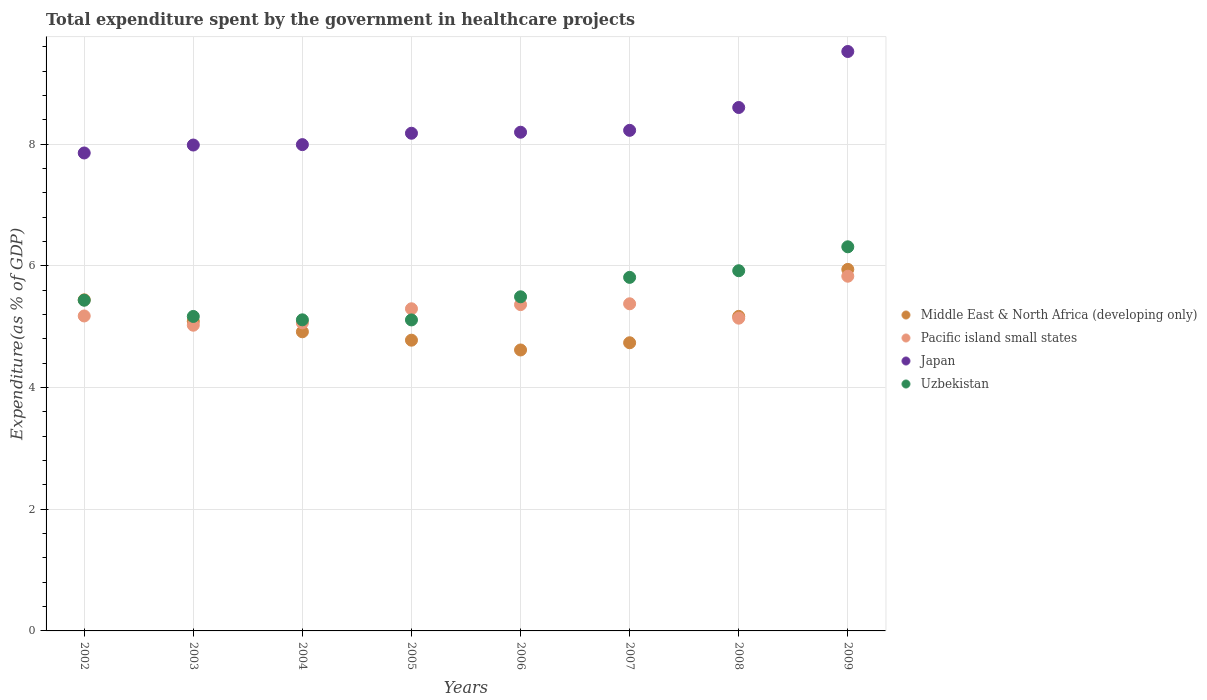What is the total expenditure spent by the government in healthcare projects in Uzbekistan in 2006?
Keep it short and to the point. 5.49. Across all years, what is the maximum total expenditure spent by the government in healthcare projects in Japan?
Keep it short and to the point. 9.53. Across all years, what is the minimum total expenditure spent by the government in healthcare projects in Middle East & North Africa (developing only)?
Offer a terse response. 4.62. In which year was the total expenditure spent by the government in healthcare projects in Japan maximum?
Offer a very short reply. 2009. What is the total total expenditure spent by the government in healthcare projects in Middle East & North Africa (developing only) in the graph?
Your answer should be very brief. 40.7. What is the difference between the total expenditure spent by the government in healthcare projects in Middle East & North Africa (developing only) in 2003 and that in 2009?
Your response must be concise. -0.85. What is the difference between the total expenditure spent by the government in healthcare projects in Middle East & North Africa (developing only) in 2006 and the total expenditure spent by the government in healthcare projects in Pacific island small states in 2003?
Provide a succinct answer. -0.41. What is the average total expenditure spent by the government in healthcare projects in Middle East & North Africa (developing only) per year?
Your answer should be compact. 5.09. In the year 2008, what is the difference between the total expenditure spent by the government in healthcare projects in Pacific island small states and total expenditure spent by the government in healthcare projects in Japan?
Your response must be concise. -3.46. In how many years, is the total expenditure spent by the government in healthcare projects in Pacific island small states greater than 2.8 %?
Your response must be concise. 8. What is the ratio of the total expenditure spent by the government in healthcare projects in Pacific island small states in 2005 to that in 2007?
Offer a terse response. 0.98. Is the difference between the total expenditure spent by the government in healthcare projects in Pacific island small states in 2005 and 2009 greater than the difference between the total expenditure spent by the government in healthcare projects in Japan in 2005 and 2009?
Offer a terse response. Yes. What is the difference between the highest and the second highest total expenditure spent by the government in healthcare projects in Middle East & North Africa (developing only)?
Your response must be concise. 0.5. What is the difference between the highest and the lowest total expenditure spent by the government in healthcare projects in Pacific island small states?
Keep it short and to the point. 0.81. In how many years, is the total expenditure spent by the government in healthcare projects in Japan greater than the average total expenditure spent by the government in healthcare projects in Japan taken over all years?
Keep it short and to the point. 2. Is the sum of the total expenditure spent by the government in healthcare projects in Pacific island small states in 2008 and 2009 greater than the maximum total expenditure spent by the government in healthcare projects in Japan across all years?
Offer a terse response. Yes. Is it the case that in every year, the sum of the total expenditure spent by the government in healthcare projects in Pacific island small states and total expenditure spent by the government in healthcare projects in Japan  is greater than the total expenditure spent by the government in healthcare projects in Uzbekistan?
Offer a terse response. Yes. Does the total expenditure spent by the government in healthcare projects in Japan monotonically increase over the years?
Your answer should be compact. Yes. Is the total expenditure spent by the government in healthcare projects in Uzbekistan strictly less than the total expenditure spent by the government in healthcare projects in Japan over the years?
Your answer should be compact. Yes. How many dotlines are there?
Keep it short and to the point. 4. How many years are there in the graph?
Your response must be concise. 8. Does the graph contain grids?
Keep it short and to the point. Yes. Where does the legend appear in the graph?
Offer a terse response. Center right. How are the legend labels stacked?
Offer a very short reply. Vertical. What is the title of the graph?
Provide a succinct answer. Total expenditure spent by the government in healthcare projects. What is the label or title of the Y-axis?
Provide a succinct answer. Expenditure(as % of GDP). What is the Expenditure(as % of GDP) in Middle East & North Africa (developing only) in 2002?
Offer a terse response. 5.44. What is the Expenditure(as % of GDP) in Pacific island small states in 2002?
Offer a very short reply. 5.18. What is the Expenditure(as % of GDP) of Japan in 2002?
Offer a very short reply. 7.86. What is the Expenditure(as % of GDP) of Uzbekistan in 2002?
Your answer should be very brief. 5.44. What is the Expenditure(as % of GDP) in Middle East & North Africa (developing only) in 2003?
Provide a succinct answer. 5.09. What is the Expenditure(as % of GDP) in Pacific island small states in 2003?
Ensure brevity in your answer.  5.03. What is the Expenditure(as % of GDP) in Japan in 2003?
Keep it short and to the point. 7.99. What is the Expenditure(as % of GDP) of Uzbekistan in 2003?
Provide a short and direct response. 5.17. What is the Expenditure(as % of GDP) of Middle East & North Africa (developing only) in 2004?
Your answer should be compact. 4.92. What is the Expenditure(as % of GDP) of Pacific island small states in 2004?
Make the answer very short. 5.06. What is the Expenditure(as % of GDP) of Japan in 2004?
Offer a terse response. 7.99. What is the Expenditure(as % of GDP) in Uzbekistan in 2004?
Offer a terse response. 5.11. What is the Expenditure(as % of GDP) in Middle East & North Africa (developing only) in 2005?
Ensure brevity in your answer.  4.78. What is the Expenditure(as % of GDP) in Pacific island small states in 2005?
Make the answer very short. 5.3. What is the Expenditure(as % of GDP) in Japan in 2005?
Offer a very short reply. 8.18. What is the Expenditure(as % of GDP) in Uzbekistan in 2005?
Keep it short and to the point. 5.11. What is the Expenditure(as % of GDP) in Middle East & North Africa (developing only) in 2006?
Offer a terse response. 4.62. What is the Expenditure(as % of GDP) in Pacific island small states in 2006?
Offer a very short reply. 5.36. What is the Expenditure(as % of GDP) in Japan in 2006?
Provide a succinct answer. 8.2. What is the Expenditure(as % of GDP) of Uzbekistan in 2006?
Give a very brief answer. 5.49. What is the Expenditure(as % of GDP) of Middle East & North Africa (developing only) in 2007?
Make the answer very short. 4.74. What is the Expenditure(as % of GDP) in Pacific island small states in 2007?
Ensure brevity in your answer.  5.38. What is the Expenditure(as % of GDP) in Japan in 2007?
Keep it short and to the point. 8.23. What is the Expenditure(as % of GDP) of Uzbekistan in 2007?
Offer a very short reply. 5.81. What is the Expenditure(as % of GDP) of Middle East & North Africa (developing only) in 2008?
Provide a short and direct response. 5.17. What is the Expenditure(as % of GDP) in Pacific island small states in 2008?
Give a very brief answer. 5.14. What is the Expenditure(as % of GDP) of Japan in 2008?
Keep it short and to the point. 8.61. What is the Expenditure(as % of GDP) of Uzbekistan in 2008?
Ensure brevity in your answer.  5.92. What is the Expenditure(as % of GDP) in Middle East & North Africa (developing only) in 2009?
Ensure brevity in your answer.  5.94. What is the Expenditure(as % of GDP) in Pacific island small states in 2009?
Give a very brief answer. 5.83. What is the Expenditure(as % of GDP) of Japan in 2009?
Your answer should be very brief. 9.53. What is the Expenditure(as % of GDP) in Uzbekistan in 2009?
Offer a very short reply. 6.31. Across all years, what is the maximum Expenditure(as % of GDP) of Middle East & North Africa (developing only)?
Give a very brief answer. 5.94. Across all years, what is the maximum Expenditure(as % of GDP) of Pacific island small states?
Your answer should be compact. 5.83. Across all years, what is the maximum Expenditure(as % of GDP) of Japan?
Your response must be concise. 9.53. Across all years, what is the maximum Expenditure(as % of GDP) in Uzbekistan?
Give a very brief answer. 6.31. Across all years, what is the minimum Expenditure(as % of GDP) in Middle East & North Africa (developing only)?
Offer a very short reply. 4.62. Across all years, what is the minimum Expenditure(as % of GDP) in Pacific island small states?
Give a very brief answer. 5.03. Across all years, what is the minimum Expenditure(as % of GDP) of Japan?
Make the answer very short. 7.86. Across all years, what is the minimum Expenditure(as % of GDP) in Uzbekistan?
Keep it short and to the point. 5.11. What is the total Expenditure(as % of GDP) in Middle East & North Africa (developing only) in the graph?
Your response must be concise. 40.7. What is the total Expenditure(as % of GDP) of Pacific island small states in the graph?
Your answer should be very brief. 42.28. What is the total Expenditure(as % of GDP) of Japan in the graph?
Your response must be concise. 66.58. What is the total Expenditure(as % of GDP) in Uzbekistan in the graph?
Your answer should be compact. 44.38. What is the difference between the Expenditure(as % of GDP) in Middle East & North Africa (developing only) in 2002 and that in 2003?
Your answer should be very brief. 0.35. What is the difference between the Expenditure(as % of GDP) of Pacific island small states in 2002 and that in 2003?
Offer a terse response. 0.15. What is the difference between the Expenditure(as % of GDP) of Japan in 2002 and that in 2003?
Give a very brief answer. -0.13. What is the difference between the Expenditure(as % of GDP) of Uzbekistan in 2002 and that in 2003?
Your answer should be compact. 0.27. What is the difference between the Expenditure(as % of GDP) in Middle East & North Africa (developing only) in 2002 and that in 2004?
Make the answer very short. 0.53. What is the difference between the Expenditure(as % of GDP) in Pacific island small states in 2002 and that in 2004?
Your answer should be very brief. 0.11. What is the difference between the Expenditure(as % of GDP) in Japan in 2002 and that in 2004?
Your answer should be compact. -0.14. What is the difference between the Expenditure(as % of GDP) of Uzbekistan in 2002 and that in 2004?
Give a very brief answer. 0.32. What is the difference between the Expenditure(as % of GDP) of Middle East & North Africa (developing only) in 2002 and that in 2005?
Offer a very short reply. 0.66. What is the difference between the Expenditure(as % of GDP) in Pacific island small states in 2002 and that in 2005?
Give a very brief answer. -0.12. What is the difference between the Expenditure(as % of GDP) of Japan in 2002 and that in 2005?
Provide a succinct answer. -0.32. What is the difference between the Expenditure(as % of GDP) of Uzbekistan in 2002 and that in 2005?
Provide a short and direct response. 0.32. What is the difference between the Expenditure(as % of GDP) of Middle East & North Africa (developing only) in 2002 and that in 2006?
Ensure brevity in your answer.  0.82. What is the difference between the Expenditure(as % of GDP) in Pacific island small states in 2002 and that in 2006?
Your answer should be very brief. -0.19. What is the difference between the Expenditure(as % of GDP) of Japan in 2002 and that in 2006?
Your answer should be compact. -0.34. What is the difference between the Expenditure(as % of GDP) of Uzbekistan in 2002 and that in 2006?
Keep it short and to the point. -0.06. What is the difference between the Expenditure(as % of GDP) in Middle East & North Africa (developing only) in 2002 and that in 2007?
Ensure brevity in your answer.  0.71. What is the difference between the Expenditure(as % of GDP) in Pacific island small states in 2002 and that in 2007?
Offer a very short reply. -0.2. What is the difference between the Expenditure(as % of GDP) in Japan in 2002 and that in 2007?
Ensure brevity in your answer.  -0.37. What is the difference between the Expenditure(as % of GDP) in Uzbekistan in 2002 and that in 2007?
Provide a succinct answer. -0.38. What is the difference between the Expenditure(as % of GDP) in Middle East & North Africa (developing only) in 2002 and that in 2008?
Ensure brevity in your answer.  0.27. What is the difference between the Expenditure(as % of GDP) in Pacific island small states in 2002 and that in 2008?
Your answer should be compact. 0.04. What is the difference between the Expenditure(as % of GDP) in Japan in 2002 and that in 2008?
Your answer should be compact. -0.75. What is the difference between the Expenditure(as % of GDP) of Uzbekistan in 2002 and that in 2008?
Ensure brevity in your answer.  -0.48. What is the difference between the Expenditure(as % of GDP) in Middle East & North Africa (developing only) in 2002 and that in 2009?
Ensure brevity in your answer.  -0.5. What is the difference between the Expenditure(as % of GDP) in Pacific island small states in 2002 and that in 2009?
Offer a very short reply. -0.65. What is the difference between the Expenditure(as % of GDP) in Japan in 2002 and that in 2009?
Make the answer very short. -1.67. What is the difference between the Expenditure(as % of GDP) in Uzbekistan in 2002 and that in 2009?
Ensure brevity in your answer.  -0.88. What is the difference between the Expenditure(as % of GDP) of Middle East & North Africa (developing only) in 2003 and that in 2004?
Offer a very short reply. 0.17. What is the difference between the Expenditure(as % of GDP) in Pacific island small states in 2003 and that in 2004?
Provide a short and direct response. -0.04. What is the difference between the Expenditure(as % of GDP) of Japan in 2003 and that in 2004?
Provide a short and direct response. -0.01. What is the difference between the Expenditure(as % of GDP) of Uzbekistan in 2003 and that in 2004?
Provide a succinct answer. 0.06. What is the difference between the Expenditure(as % of GDP) of Middle East & North Africa (developing only) in 2003 and that in 2005?
Keep it short and to the point. 0.31. What is the difference between the Expenditure(as % of GDP) in Pacific island small states in 2003 and that in 2005?
Give a very brief answer. -0.27. What is the difference between the Expenditure(as % of GDP) in Japan in 2003 and that in 2005?
Provide a short and direct response. -0.19. What is the difference between the Expenditure(as % of GDP) of Uzbekistan in 2003 and that in 2005?
Make the answer very short. 0.06. What is the difference between the Expenditure(as % of GDP) in Middle East & North Africa (developing only) in 2003 and that in 2006?
Your answer should be compact. 0.47. What is the difference between the Expenditure(as % of GDP) in Pacific island small states in 2003 and that in 2006?
Ensure brevity in your answer.  -0.34. What is the difference between the Expenditure(as % of GDP) in Japan in 2003 and that in 2006?
Your answer should be compact. -0.21. What is the difference between the Expenditure(as % of GDP) in Uzbekistan in 2003 and that in 2006?
Offer a terse response. -0.32. What is the difference between the Expenditure(as % of GDP) in Middle East & North Africa (developing only) in 2003 and that in 2007?
Offer a very short reply. 0.35. What is the difference between the Expenditure(as % of GDP) in Pacific island small states in 2003 and that in 2007?
Offer a terse response. -0.35. What is the difference between the Expenditure(as % of GDP) in Japan in 2003 and that in 2007?
Your response must be concise. -0.24. What is the difference between the Expenditure(as % of GDP) of Uzbekistan in 2003 and that in 2007?
Offer a terse response. -0.64. What is the difference between the Expenditure(as % of GDP) in Middle East & North Africa (developing only) in 2003 and that in 2008?
Give a very brief answer. -0.08. What is the difference between the Expenditure(as % of GDP) in Pacific island small states in 2003 and that in 2008?
Your response must be concise. -0.12. What is the difference between the Expenditure(as % of GDP) of Japan in 2003 and that in 2008?
Your answer should be very brief. -0.62. What is the difference between the Expenditure(as % of GDP) in Uzbekistan in 2003 and that in 2008?
Offer a terse response. -0.75. What is the difference between the Expenditure(as % of GDP) of Middle East & North Africa (developing only) in 2003 and that in 2009?
Give a very brief answer. -0.85. What is the difference between the Expenditure(as % of GDP) of Pacific island small states in 2003 and that in 2009?
Offer a terse response. -0.81. What is the difference between the Expenditure(as % of GDP) in Japan in 2003 and that in 2009?
Offer a terse response. -1.54. What is the difference between the Expenditure(as % of GDP) in Uzbekistan in 2003 and that in 2009?
Offer a very short reply. -1.14. What is the difference between the Expenditure(as % of GDP) in Middle East & North Africa (developing only) in 2004 and that in 2005?
Provide a short and direct response. 0.14. What is the difference between the Expenditure(as % of GDP) in Pacific island small states in 2004 and that in 2005?
Your response must be concise. -0.23. What is the difference between the Expenditure(as % of GDP) of Japan in 2004 and that in 2005?
Keep it short and to the point. -0.19. What is the difference between the Expenditure(as % of GDP) in Uzbekistan in 2004 and that in 2005?
Offer a terse response. 0. What is the difference between the Expenditure(as % of GDP) in Middle East & North Africa (developing only) in 2004 and that in 2006?
Provide a short and direct response. 0.3. What is the difference between the Expenditure(as % of GDP) in Pacific island small states in 2004 and that in 2006?
Provide a short and direct response. -0.3. What is the difference between the Expenditure(as % of GDP) in Japan in 2004 and that in 2006?
Provide a short and direct response. -0.2. What is the difference between the Expenditure(as % of GDP) of Uzbekistan in 2004 and that in 2006?
Give a very brief answer. -0.38. What is the difference between the Expenditure(as % of GDP) in Middle East & North Africa (developing only) in 2004 and that in 2007?
Your answer should be compact. 0.18. What is the difference between the Expenditure(as % of GDP) in Pacific island small states in 2004 and that in 2007?
Your answer should be very brief. -0.31. What is the difference between the Expenditure(as % of GDP) of Japan in 2004 and that in 2007?
Make the answer very short. -0.23. What is the difference between the Expenditure(as % of GDP) in Uzbekistan in 2004 and that in 2007?
Your response must be concise. -0.7. What is the difference between the Expenditure(as % of GDP) of Middle East & North Africa (developing only) in 2004 and that in 2008?
Ensure brevity in your answer.  -0.25. What is the difference between the Expenditure(as % of GDP) of Pacific island small states in 2004 and that in 2008?
Provide a short and direct response. -0.08. What is the difference between the Expenditure(as % of GDP) of Japan in 2004 and that in 2008?
Keep it short and to the point. -0.61. What is the difference between the Expenditure(as % of GDP) of Uzbekistan in 2004 and that in 2008?
Your answer should be very brief. -0.81. What is the difference between the Expenditure(as % of GDP) in Middle East & North Africa (developing only) in 2004 and that in 2009?
Provide a short and direct response. -1.03. What is the difference between the Expenditure(as % of GDP) of Pacific island small states in 2004 and that in 2009?
Ensure brevity in your answer.  -0.77. What is the difference between the Expenditure(as % of GDP) of Japan in 2004 and that in 2009?
Make the answer very short. -1.53. What is the difference between the Expenditure(as % of GDP) in Uzbekistan in 2004 and that in 2009?
Your answer should be compact. -1.2. What is the difference between the Expenditure(as % of GDP) in Middle East & North Africa (developing only) in 2005 and that in 2006?
Keep it short and to the point. 0.16. What is the difference between the Expenditure(as % of GDP) of Pacific island small states in 2005 and that in 2006?
Make the answer very short. -0.07. What is the difference between the Expenditure(as % of GDP) of Japan in 2005 and that in 2006?
Ensure brevity in your answer.  -0.02. What is the difference between the Expenditure(as % of GDP) in Uzbekistan in 2005 and that in 2006?
Your response must be concise. -0.38. What is the difference between the Expenditure(as % of GDP) of Middle East & North Africa (developing only) in 2005 and that in 2007?
Ensure brevity in your answer.  0.04. What is the difference between the Expenditure(as % of GDP) of Pacific island small states in 2005 and that in 2007?
Your response must be concise. -0.08. What is the difference between the Expenditure(as % of GDP) of Japan in 2005 and that in 2007?
Keep it short and to the point. -0.05. What is the difference between the Expenditure(as % of GDP) of Uzbekistan in 2005 and that in 2007?
Offer a very short reply. -0.7. What is the difference between the Expenditure(as % of GDP) of Middle East & North Africa (developing only) in 2005 and that in 2008?
Keep it short and to the point. -0.39. What is the difference between the Expenditure(as % of GDP) in Pacific island small states in 2005 and that in 2008?
Provide a short and direct response. 0.15. What is the difference between the Expenditure(as % of GDP) in Japan in 2005 and that in 2008?
Offer a terse response. -0.42. What is the difference between the Expenditure(as % of GDP) of Uzbekistan in 2005 and that in 2008?
Provide a short and direct response. -0.81. What is the difference between the Expenditure(as % of GDP) of Middle East & North Africa (developing only) in 2005 and that in 2009?
Offer a very short reply. -1.16. What is the difference between the Expenditure(as % of GDP) of Pacific island small states in 2005 and that in 2009?
Offer a terse response. -0.54. What is the difference between the Expenditure(as % of GDP) of Japan in 2005 and that in 2009?
Offer a very short reply. -1.34. What is the difference between the Expenditure(as % of GDP) in Uzbekistan in 2005 and that in 2009?
Your answer should be very brief. -1.2. What is the difference between the Expenditure(as % of GDP) in Middle East & North Africa (developing only) in 2006 and that in 2007?
Give a very brief answer. -0.12. What is the difference between the Expenditure(as % of GDP) of Pacific island small states in 2006 and that in 2007?
Keep it short and to the point. -0.01. What is the difference between the Expenditure(as % of GDP) in Japan in 2006 and that in 2007?
Your answer should be compact. -0.03. What is the difference between the Expenditure(as % of GDP) in Uzbekistan in 2006 and that in 2007?
Offer a terse response. -0.32. What is the difference between the Expenditure(as % of GDP) of Middle East & North Africa (developing only) in 2006 and that in 2008?
Offer a very short reply. -0.55. What is the difference between the Expenditure(as % of GDP) in Pacific island small states in 2006 and that in 2008?
Provide a short and direct response. 0.22. What is the difference between the Expenditure(as % of GDP) in Japan in 2006 and that in 2008?
Offer a terse response. -0.41. What is the difference between the Expenditure(as % of GDP) of Uzbekistan in 2006 and that in 2008?
Provide a short and direct response. -0.43. What is the difference between the Expenditure(as % of GDP) of Middle East & North Africa (developing only) in 2006 and that in 2009?
Ensure brevity in your answer.  -1.32. What is the difference between the Expenditure(as % of GDP) of Pacific island small states in 2006 and that in 2009?
Offer a terse response. -0.47. What is the difference between the Expenditure(as % of GDP) in Japan in 2006 and that in 2009?
Ensure brevity in your answer.  -1.33. What is the difference between the Expenditure(as % of GDP) of Uzbekistan in 2006 and that in 2009?
Your answer should be compact. -0.82. What is the difference between the Expenditure(as % of GDP) of Middle East & North Africa (developing only) in 2007 and that in 2008?
Offer a terse response. -0.43. What is the difference between the Expenditure(as % of GDP) of Pacific island small states in 2007 and that in 2008?
Make the answer very short. 0.24. What is the difference between the Expenditure(as % of GDP) of Japan in 2007 and that in 2008?
Provide a short and direct response. -0.38. What is the difference between the Expenditure(as % of GDP) in Uzbekistan in 2007 and that in 2008?
Make the answer very short. -0.11. What is the difference between the Expenditure(as % of GDP) in Middle East & North Africa (developing only) in 2007 and that in 2009?
Provide a short and direct response. -1.21. What is the difference between the Expenditure(as % of GDP) of Pacific island small states in 2007 and that in 2009?
Make the answer very short. -0.45. What is the difference between the Expenditure(as % of GDP) of Japan in 2007 and that in 2009?
Your response must be concise. -1.3. What is the difference between the Expenditure(as % of GDP) in Uzbekistan in 2007 and that in 2009?
Your answer should be very brief. -0.5. What is the difference between the Expenditure(as % of GDP) of Middle East & North Africa (developing only) in 2008 and that in 2009?
Offer a very short reply. -0.77. What is the difference between the Expenditure(as % of GDP) in Pacific island small states in 2008 and that in 2009?
Make the answer very short. -0.69. What is the difference between the Expenditure(as % of GDP) in Japan in 2008 and that in 2009?
Your response must be concise. -0.92. What is the difference between the Expenditure(as % of GDP) of Uzbekistan in 2008 and that in 2009?
Offer a very short reply. -0.39. What is the difference between the Expenditure(as % of GDP) in Middle East & North Africa (developing only) in 2002 and the Expenditure(as % of GDP) in Pacific island small states in 2003?
Provide a short and direct response. 0.42. What is the difference between the Expenditure(as % of GDP) of Middle East & North Africa (developing only) in 2002 and the Expenditure(as % of GDP) of Japan in 2003?
Offer a very short reply. -2.55. What is the difference between the Expenditure(as % of GDP) of Middle East & North Africa (developing only) in 2002 and the Expenditure(as % of GDP) of Uzbekistan in 2003?
Ensure brevity in your answer.  0.27. What is the difference between the Expenditure(as % of GDP) in Pacific island small states in 2002 and the Expenditure(as % of GDP) in Japan in 2003?
Offer a very short reply. -2.81. What is the difference between the Expenditure(as % of GDP) in Pacific island small states in 2002 and the Expenditure(as % of GDP) in Uzbekistan in 2003?
Keep it short and to the point. 0.01. What is the difference between the Expenditure(as % of GDP) in Japan in 2002 and the Expenditure(as % of GDP) in Uzbekistan in 2003?
Your answer should be very brief. 2.69. What is the difference between the Expenditure(as % of GDP) of Middle East & North Africa (developing only) in 2002 and the Expenditure(as % of GDP) of Pacific island small states in 2004?
Offer a terse response. 0.38. What is the difference between the Expenditure(as % of GDP) in Middle East & North Africa (developing only) in 2002 and the Expenditure(as % of GDP) in Japan in 2004?
Your response must be concise. -2.55. What is the difference between the Expenditure(as % of GDP) in Middle East & North Africa (developing only) in 2002 and the Expenditure(as % of GDP) in Uzbekistan in 2004?
Make the answer very short. 0.33. What is the difference between the Expenditure(as % of GDP) of Pacific island small states in 2002 and the Expenditure(as % of GDP) of Japan in 2004?
Provide a succinct answer. -2.82. What is the difference between the Expenditure(as % of GDP) in Pacific island small states in 2002 and the Expenditure(as % of GDP) in Uzbekistan in 2004?
Provide a succinct answer. 0.06. What is the difference between the Expenditure(as % of GDP) of Japan in 2002 and the Expenditure(as % of GDP) of Uzbekistan in 2004?
Your response must be concise. 2.74. What is the difference between the Expenditure(as % of GDP) of Middle East & North Africa (developing only) in 2002 and the Expenditure(as % of GDP) of Pacific island small states in 2005?
Make the answer very short. 0.15. What is the difference between the Expenditure(as % of GDP) in Middle East & North Africa (developing only) in 2002 and the Expenditure(as % of GDP) in Japan in 2005?
Your answer should be very brief. -2.74. What is the difference between the Expenditure(as % of GDP) of Middle East & North Africa (developing only) in 2002 and the Expenditure(as % of GDP) of Uzbekistan in 2005?
Keep it short and to the point. 0.33. What is the difference between the Expenditure(as % of GDP) of Pacific island small states in 2002 and the Expenditure(as % of GDP) of Japan in 2005?
Your response must be concise. -3. What is the difference between the Expenditure(as % of GDP) in Pacific island small states in 2002 and the Expenditure(as % of GDP) in Uzbekistan in 2005?
Offer a terse response. 0.07. What is the difference between the Expenditure(as % of GDP) in Japan in 2002 and the Expenditure(as % of GDP) in Uzbekistan in 2005?
Make the answer very short. 2.74. What is the difference between the Expenditure(as % of GDP) of Middle East & North Africa (developing only) in 2002 and the Expenditure(as % of GDP) of Pacific island small states in 2006?
Offer a terse response. 0.08. What is the difference between the Expenditure(as % of GDP) of Middle East & North Africa (developing only) in 2002 and the Expenditure(as % of GDP) of Japan in 2006?
Make the answer very short. -2.76. What is the difference between the Expenditure(as % of GDP) of Middle East & North Africa (developing only) in 2002 and the Expenditure(as % of GDP) of Uzbekistan in 2006?
Your answer should be very brief. -0.05. What is the difference between the Expenditure(as % of GDP) in Pacific island small states in 2002 and the Expenditure(as % of GDP) in Japan in 2006?
Your response must be concise. -3.02. What is the difference between the Expenditure(as % of GDP) in Pacific island small states in 2002 and the Expenditure(as % of GDP) in Uzbekistan in 2006?
Provide a short and direct response. -0.32. What is the difference between the Expenditure(as % of GDP) of Japan in 2002 and the Expenditure(as % of GDP) of Uzbekistan in 2006?
Provide a short and direct response. 2.36. What is the difference between the Expenditure(as % of GDP) in Middle East & North Africa (developing only) in 2002 and the Expenditure(as % of GDP) in Pacific island small states in 2007?
Offer a terse response. 0.06. What is the difference between the Expenditure(as % of GDP) in Middle East & North Africa (developing only) in 2002 and the Expenditure(as % of GDP) in Japan in 2007?
Provide a short and direct response. -2.79. What is the difference between the Expenditure(as % of GDP) in Middle East & North Africa (developing only) in 2002 and the Expenditure(as % of GDP) in Uzbekistan in 2007?
Make the answer very short. -0.37. What is the difference between the Expenditure(as % of GDP) of Pacific island small states in 2002 and the Expenditure(as % of GDP) of Japan in 2007?
Your response must be concise. -3.05. What is the difference between the Expenditure(as % of GDP) in Pacific island small states in 2002 and the Expenditure(as % of GDP) in Uzbekistan in 2007?
Provide a short and direct response. -0.63. What is the difference between the Expenditure(as % of GDP) of Japan in 2002 and the Expenditure(as % of GDP) of Uzbekistan in 2007?
Offer a very short reply. 2.05. What is the difference between the Expenditure(as % of GDP) in Middle East & North Africa (developing only) in 2002 and the Expenditure(as % of GDP) in Pacific island small states in 2008?
Ensure brevity in your answer.  0.3. What is the difference between the Expenditure(as % of GDP) in Middle East & North Africa (developing only) in 2002 and the Expenditure(as % of GDP) in Japan in 2008?
Keep it short and to the point. -3.16. What is the difference between the Expenditure(as % of GDP) in Middle East & North Africa (developing only) in 2002 and the Expenditure(as % of GDP) in Uzbekistan in 2008?
Ensure brevity in your answer.  -0.48. What is the difference between the Expenditure(as % of GDP) in Pacific island small states in 2002 and the Expenditure(as % of GDP) in Japan in 2008?
Your response must be concise. -3.43. What is the difference between the Expenditure(as % of GDP) of Pacific island small states in 2002 and the Expenditure(as % of GDP) of Uzbekistan in 2008?
Offer a very short reply. -0.74. What is the difference between the Expenditure(as % of GDP) of Japan in 2002 and the Expenditure(as % of GDP) of Uzbekistan in 2008?
Your answer should be compact. 1.94. What is the difference between the Expenditure(as % of GDP) in Middle East & North Africa (developing only) in 2002 and the Expenditure(as % of GDP) in Pacific island small states in 2009?
Your response must be concise. -0.39. What is the difference between the Expenditure(as % of GDP) of Middle East & North Africa (developing only) in 2002 and the Expenditure(as % of GDP) of Japan in 2009?
Offer a very short reply. -4.08. What is the difference between the Expenditure(as % of GDP) in Middle East & North Africa (developing only) in 2002 and the Expenditure(as % of GDP) in Uzbekistan in 2009?
Offer a terse response. -0.87. What is the difference between the Expenditure(as % of GDP) in Pacific island small states in 2002 and the Expenditure(as % of GDP) in Japan in 2009?
Ensure brevity in your answer.  -4.35. What is the difference between the Expenditure(as % of GDP) of Pacific island small states in 2002 and the Expenditure(as % of GDP) of Uzbekistan in 2009?
Make the answer very short. -1.14. What is the difference between the Expenditure(as % of GDP) of Japan in 2002 and the Expenditure(as % of GDP) of Uzbekistan in 2009?
Offer a very short reply. 1.54. What is the difference between the Expenditure(as % of GDP) of Middle East & North Africa (developing only) in 2003 and the Expenditure(as % of GDP) of Pacific island small states in 2004?
Offer a terse response. 0.03. What is the difference between the Expenditure(as % of GDP) in Middle East & North Africa (developing only) in 2003 and the Expenditure(as % of GDP) in Japan in 2004?
Give a very brief answer. -2.9. What is the difference between the Expenditure(as % of GDP) of Middle East & North Africa (developing only) in 2003 and the Expenditure(as % of GDP) of Uzbekistan in 2004?
Make the answer very short. -0.02. What is the difference between the Expenditure(as % of GDP) in Pacific island small states in 2003 and the Expenditure(as % of GDP) in Japan in 2004?
Give a very brief answer. -2.97. What is the difference between the Expenditure(as % of GDP) of Pacific island small states in 2003 and the Expenditure(as % of GDP) of Uzbekistan in 2004?
Keep it short and to the point. -0.09. What is the difference between the Expenditure(as % of GDP) of Japan in 2003 and the Expenditure(as % of GDP) of Uzbekistan in 2004?
Offer a terse response. 2.87. What is the difference between the Expenditure(as % of GDP) in Middle East & North Africa (developing only) in 2003 and the Expenditure(as % of GDP) in Pacific island small states in 2005?
Provide a short and direct response. -0.21. What is the difference between the Expenditure(as % of GDP) of Middle East & North Africa (developing only) in 2003 and the Expenditure(as % of GDP) of Japan in 2005?
Give a very brief answer. -3.09. What is the difference between the Expenditure(as % of GDP) of Middle East & North Africa (developing only) in 2003 and the Expenditure(as % of GDP) of Uzbekistan in 2005?
Provide a succinct answer. -0.02. What is the difference between the Expenditure(as % of GDP) of Pacific island small states in 2003 and the Expenditure(as % of GDP) of Japan in 2005?
Your response must be concise. -3.16. What is the difference between the Expenditure(as % of GDP) in Pacific island small states in 2003 and the Expenditure(as % of GDP) in Uzbekistan in 2005?
Your response must be concise. -0.09. What is the difference between the Expenditure(as % of GDP) in Japan in 2003 and the Expenditure(as % of GDP) in Uzbekistan in 2005?
Make the answer very short. 2.88. What is the difference between the Expenditure(as % of GDP) of Middle East & North Africa (developing only) in 2003 and the Expenditure(as % of GDP) of Pacific island small states in 2006?
Provide a short and direct response. -0.27. What is the difference between the Expenditure(as % of GDP) in Middle East & North Africa (developing only) in 2003 and the Expenditure(as % of GDP) in Japan in 2006?
Keep it short and to the point. -3.11. What is the difference between the Expenditure(as % of GDP) in Middle East & North Africa (developing only) in 2003 and the Expenditure(as % of GDP) in Uzbekistan in 2006?
Make the answer very short. -0.4. What is the difference between the Expenditure(as % of GDP) of Pacific island small states in 2003 and the Expenditure(as % of GDP) of Japan in 2006?
Provide a succinct answer. -3.17. What is the difference between the Expenditure(as % of GDP) of Pacific island small states in 2003 and the Expenditure(as % of GDP) of Uzbekistan in 2006?
Ensure brevity in your answer.  -0.47. What is the difference between the Expenditure(as % of GDP) of Japan in 2003 and the Expenditure(as % of GDP) of Uzbekistan in 2006?
Make the answer very short. 2.5. What is the difference between the Expenditure(as % of GDP) in Middle East & North Africa (developing only) in 2003 and the Expenditure(as % of GDP) in Pacific island small states in 2007?
Your answer should be compact. -0.29. What is the difference between the Expenditure(as % of GDP) in Middle East & North Africa (developing only) in 2003 and the Expenditure(as % of GDP) in Japan in 2007?
Provide a short and direct response. -3.14. What is the difference between the Expenditure(as % of GDP) of Middle East & North Africa (developing only) in 2003 and the Expenditure(as % of GDP) of Uzbekistan in 2007?
Ensure brevity in your answer.  -0.72. What is the difference between the Expenditure(as % of GDP) in Pacific island small states in 2003 and the Expenditure(as % of GDP) in Japan in 2007?
Your response must be concise. -3.2. What is the difference between the Expenditure(as % of GDP) in Pacific island small states in 2003 and the Expenditure(as % of GDP) in Uzbekistan in 2007?
Give a very brief answer. -0.79. What is the difference between the Expenditure(as % of GDP) of Japan in 2003 and the Expenditure(as % of GDP) of Uzbekistan in 2007?
Your response must be concise. 2.18. What is the difference between the Expenditure(as % of GDP) of Middle East & North Africa (developing only) in 2003 and the Expenditure(as % of GDP) of Pacific island small states in 2008?
Provide a short and direct response. -0.05. What is the difference between the Expenditure(as % of GDP) of Middle East & North Africa (developing only) in 2003 and the Expenditure(as % of GDP) of Japan in 2008?
Offer a terse response. -3.52. What is the difference between the Expenditure(as % of GDP) in Middle East & North Africa (developing only) in 2003 and the Expenditure(as % of GDP) in Uzbekistan in 2008?
Make the answer very short. -0.83. What is the difference between the Expenditure(as % of GDP) in Pacific island small states in 2003 and the Expenditure(as % of GDP) in Japan in 2008?
Make the answer very short. -3.58. What is the difference between the Expenditure(as % of GDP) of Pacific island small states in 2003 and the Expenditure(as % of GDP) of Uzbekistan in 2008?
Give a very brief answer. -0.9. What is the difference between the Expenditure(as % of GDP) of Japan in 2003 and the Expenditure(as % of GDP) of Uzbekistan in 2008?
Your answer should be compact. 2.07. What is the difference between the Expenditure(as % of GDP) of Middle East & North Africa (developing only) in 2003 and the Expenditure(as % of GDP) of Pacific island small states in 2009?
Make the answer very short. -0.74. What is the difference between the Expenditure(as % of GDP) of Middle East & North Africa (developing only) in 2003 and the Expenditure(as % of GDP) of Japan in 2009?
Offer a terse response. -4.44. What is the difference between the Expenditure(as % of GDP) of Middle East & North Africa (developing only) in 2003 and the Expenditure(as % of GDP) of Uzbekistan in 2009?
Make the answer very short. -1.23. What is the difference between the Expenditure(as % of GDP) of Pacific island small states in 2003 and the Expenditure(as % of GDP) of Japan in 2009?
Ensure brevity in your answer.  -4.5. What is the difference between the Expenditure(as % of GDP) in Pacific island small states in 2003 and the Expenditure(as % of GDP) in Uzbekistan in 2009?
Keep it short and to the point. -1.29. What is the difference between the Expenditure(as % of GDP) of Japan in 2003 and the Expenditure(as % of GDP) of Uzbekistan in 2009?
Give a very brief answer. 1.67. What is the difference between the Expenditure(as % of GDP) of Middle East & North Africa (developing only) in 2004 and the Expenditure(as % of GDP) of Pacific island small states in 2005?
Your answer should be compact. -0.38. What is the difference between the Expenditure(as % of GDP) in Middle East & North Africa (developing only) in 2004 and the Expenditure(as % of GDP) in Japan in 2005?
Offer a very short reply. -3.26. What is the difference between the Expenditure(as % of GDP) in Middle East & North Africa (developing only) in 2004 and the Expenditure(as % of GDP) in Uzbekistan in 2005?
Provide a succinct answer. -0.2. What is the difference between the Expenditure(as % of GDP) of Pacific island small states in 2004 and the Expenditure(as % of GDP) of Japan in 2005?
Provide a short and direct response. -3.12. What is the difference between the Expenditure(as % of GDP) in Pacific island small states in 2004 and the Expenditure(as % of GDP) in Uzbekistan in 2005?
Offer a terse response. -0.05. What is the difference between the Expenditure(as % of GDP) of Japan in 2004 and the Expenditure(as % of GDP) of Uzbekistan in 2005?
Provide a short and direct response. 2.88. What is the difference between the Expenditure(as % of GDP) in Middle East & North Africa (developing only) in 2004 and the Expenditure(as % of GDP) in Pacific island small states in 2006?
Your answer should be compact. -0.45. What is the difference between the Expenditure(as % of GDP) of Middle East & North Africa (developing only) in 2004 and the Expenditure(as % of GDP) of Japan in 2006?
Offer a terse response. -3.28. What is the difference between the Expenditure(as % of GDP) in Middle East & North Africa (developing only) in 2004 and the Expenditure(as % of GDP) in Uzbekistan in 2006?
Your answer should be compact. -0.58. What is the difference between the Expenditure(as % of GDP) of Pacific island small states in 2004 and the Expenditure(as % of GDP) of Japan in 2006?
Your answer should be very brief. -3.13. What is the difference between the Expenditure(as % of GDP) of Pacific island small states in 2004 and the Expenditure(as % of GDP) of Uzbekistan in 2006?
Ensure brevity in your answer.  -0.43. What is the difference between the Expenditure(as % of GDP) in Japan in 2004 and the Expenditure(as % of GDP) in Uzbekistan in 2006?
Offer a very short reply. 2.5. What is the difference between the Expenditure(as % of GDP) in Middle East & North Africa (developing only) in 2004 and the Expenditure(as % of GDP) in Pacific island small states in 2007?
Give a very brief answer. -0.46. What is the difference between the Expenditure(as % of GDP) of Middle East & North Africa (developing only) in 2004 and the Expenditure(as % of GDP) of Japan in 2007?
Provide a short and direct response. -3.31. What is the difference between the Expenditure(as % of GDP) of Middle East & North Africa (developing only) in 2004 and the Expenditure(as % of GDP) of Uzbekistan in 2007?
Keep it short and to the point. -0.89. What is the difference between the Expenditure(as % of GDP) in Pacific island small states in 2004 and the Expenditure(as % of GDP) in Japan in 2007?
Offer a very short reply. -3.17. What is the difference between the Expenditure(as % of GDP) in Pacific island small states in 2004 and the Expenditure(as % of GDP) in Uzbekistan in 2007?
Ensure brevity in your answer.  -0.75. What is the difference between the Expenditure(as % of GDP) of Japan in 2004 and the Expenditure(as % of GDP) of Uzbekistan in 2007?
Provide a short and direct response. 2.18. What is the difference between the Expenditure(as % of GDP) of Middle East & North Africa (developing only) in 2004 and the Expenditure(as % of GDP) of Pacific island small states in 2008?
Your answer should be compact. -0.22. What is the difference between the Expenditure(as % of GDP) of Middle East & North Africa (developing only) in 2004 and the Expenditure(as % of GDP) of Japan in 2008?
Ensure brevity in your answer.  -3.69. What is the difference between the Expenditure(as % of GDP) of Middle East & North Africa (developing only) in 2004 and the Expenditure(as % of GDP) of Uzbekistan in 2008?
Provide a short and direct response. -1. What is the difference between the Expenditure(as % of GDP) in Pacific island small states in 2004 and the Expenditure(as % of GDP) in Japan in 2008?
Your answer should be very brief. -3.54. What is the difference between the Expenditure(as % of GDP) in Pacific island small states in 2004 and the Expenditure(as % of GDP) in Uzbekistan in 2008?
Your answer should be compact. -0.86. What is the difference between the Expenditure(as % of GDP) in Japan in 2004 and the Expenditure(as % of GDP) in Uzbekistan in 2008?
Provide a short and direct response. 2.07. What is the difference between the Expenditure(as % of GDP) of Middle East & North Africa (developing only) in 2004 and the Expenditure(as % of GDP) of Pacific island small states in 2009?
Make the answer very short. -0.91. What is the difference between the Expenditure(as % of GDP) in Middle East & North Africa (developing only) in 2004 and the Expenditure(as % of GDP) in Japan in 2009?
Offer a very short reply. -4.61. What is the difference between the Expenditure(as % of GDP) of Middle East & North Africa (developing only) in 2004 and the Expenditure(as % of GDP) of Uzbekistan in 2009?
Make the answer very short. -1.4. What is the difference between the Expenditure(as % of GDP) in Pacific island small states in 2004 and the Expenditure(as % of GDP) in Japan in 2009?
Your response must be concise. -4.46. What is the difference between the Expenditure(as % of GDP) in Pacific island small states in 2004 and the Expenditure(as % of GDP) in Uzbekistan in 2009?
Your answer should be compact. -1.25. What is the difference between the Expenditure(as % of GDP) of Japan in 2004 and the Expenditure(as % of GDP) of Uzbekistan in 2009?
Give a very brief answer. 1.68. What is the difference between the Expenditure(as % of GDP) of Middle East & North Africa (developing only) in 2005 and the Expenditure(as % of GDP) of Pacific island small states in 2006?
Provide a succinct answer. -0.58. What is the difference between the Expenditure(as % of GDP) in Middle East & North Africa (developing only) in 2005 and the Expenditure(as % of GDP) in Japan in 2006?
Provide a succinct answer. -3.42. What is the difference between the Expenditure(as % of GDP) in Middle East & North Africa (developing only) in 2005 and the Expenditure(as % of GDP) in Uzbekistan in 2006?
Your response must be concise. -0.71. What is the difference between the Expenditure(as % of GDP) in Pacific island small states in 2005 and the Expenditure(as % of GDP) in Japan in 2006?
Provide a short and direct response. -2.9. What is the difference between the Expenditure(as % of GDP) in Pacific island small states in 2005 and the Expenditure(as % of GDP) in Uzbekistan in 2006?
Provide a succinct answer. -0.2. What is the difference between the Expenditure(as % of GDP) in Japan in 2005 and the Expenditure(as % of GDP) in Uzbekistan in 2006?
Provide a succinct answer. 2.69. What is the difference between the Expenditure(as % of GDP) of Middle East & North Africa (developing only) in 2005 and the Expenditure(as % of GDP) of Pacific island small states in 2007?
Provide a short and direct response. -0.6. What is the difference between the Expenditure(as % of GDP) in Middle East & North Africa (developing only) in 2005 and the Expenditure(as % of GDP) in Japan in 2007?
Your answer should be compact. -3.45. What is the difference between the Expenditure(as % of GDP) in Middle East & North Africa (developing only) in 2005 and the Expenditure(as % of GDP) in Uzbekistan in 2007?
Provide a short and direct response. -1.03. What is the difference between the Expenditure(as % of GDP) of Pacific island small states in 2005 and the Expenditure(as % of GDP) of Japan in 2007?
Provide a short and direct response. -2.93. What is the difference between the Expenditure(as % of GDP) of Pacific island small states in 2005 and the Expenditure(as % of GDP) of Uzbekistan in 2007?
Give a very brief answer. -0.52. What is the difference between the Expenditure(as % of GDP) in Japan in 2005 and the Expenditure(as % of GDP) in Uzbekistan in 2007?
Your answer should be compact. 2.37. What is the difference between the Expenditure(as % of GDP) of Middle East & North Africa (developing only) in 2005 and the Expenditure(as % of GDP) of Pacific island small states in 2008?
Offer a terse response. -0.36. What is the difference between the Expenditure(as % of GDP) in Middle East & North Africa (developing only) in 2005 and the Expenditure(as % of GDP) in Japan in 2008?
Your answer should be very brief. -3.83. What is the difference between the Expenditure(as % of GDP) of Middle East & North Africa (developing only) in 2005 and the Expenditure(as % of GDP) of Uzbekistan in 2008?
Your answer should be compact. -1.14. What is the difference between the Expenditure(as % of GDP) of Pacific island small states in 2005 and the Expenditure(as % of GDP) of Japan in 2008?
Ensure brevity in your answer.  -3.31. What is the difference between the Expenditure(as % of GDP) of Pacific island small states in 2005 and the Expenditure(as % of GDP) of Uzbekistan in 2008?
Provide a short and direct response. -0.63. What is the difference between the Expenditure(as % of GDP) of Japan in 2005 and the Expenditure(as % of GDP) of Uzbekistan in 2008?
Ensure brevity in your answer.  2.26. What is the difference between the Expenditure(as % of GDP) of Middle East & North Africa (developing only) in 2005 and the Expenditure(as % of GDP) of Pacific island small states in 2009?
Provide a succinct answer. -1.05. What is the difference between the Expenditure(as % of GDP) of Middle East & North Africa (developing only) in 2005 and the Expenditure(as % of GDP) of Japan in 2009?
Your answer should be compact. -4.75. What is the difference between the Expenditure(as % of GDP) of Middle East & North Africa (developing only) in 2005 and the Expenditure(as % of GDP) of Uzbekistan in 2009?
Offer a terse response. -1.54. What is the difference between the Expenditure(as % of GDP) of Pacific island small states in 2005 and the Expenditure(as % of GDP) of Japan in 2009?
Keep it short and to the point. -4.23. What is the difference between the Expenditure(as % of GDP) in Pacific island small states in 2005 and the Expenditure(as % of GDP) in Uzbekistan in 2009?
Keep it short and to the point. -1.02. What is the difference between the Expenditure(as % of GDP) of Japan in 2005 and the Expenditure(as % of GDP) of Uzbekistan in 2009?
Keep it short and to the point. 1.87. What is the difference between the Expenditure(as % of GDP) in Middle East & North Africa (developing only) in 2006 and the Expenditure(as % of GDP) in Pacific island small states in 2007?
Offer a terse response. -0.76. What is the difference between the Expenditure(as % of GDP) in Middle East & North Africa (developing only) in 2006 and the Expenditure(as % of GDP) in Japan in 2007?
Offer a terse response. -3.61. What is the difference between the Expenditure(as % of GDP) in Middle East & North Africa (developing only) in 2006 and the Expenditure(as % of GDP) in Uzbekistan in 2007?
Make the answer very short. -1.19. What is the difference between the Expenditure(as % of GDP) of Pacific island small states in 2006 and the Expenditure(as % of GDP) of Japan in 2007?
Provide a succinct answer. -2.87. What is the difference between the Expenditure(as % of GDP) in Pacific island small states in 2006 and the Expenditure(as % of GDP) in Uzbekistan in 2007?
Offer a very short reply. -0.45. What is the difference between the Expenditure(as % of GDP) of Japan in 2006 and the Expenditure(as % of GDP) of Uzbekistan in 2007?
Your answer should be very brief. 2.39. What is the difference between the Expenditure(as % of GDP) in Middle East & North Africa (developing only) in 2006 and the Expenditure(as % of GDP) in Pacific island small states in 2008?
Your response must be concise. -0.52. What is the difference between the Expenditure(as % of GDP) in Middle East & North Africa (developing only) in 2006 and the Expenditure(as % of GDP) in Japan in 2008?
Make the answer very short. -3.99. What is the difference between the Expenditure(as % of GDP) of Middle East & North Africa (developing only) in 2006 and the Expenditure(as % of GDP) of Uzbekistan in 2008?
Keep it short and to the point. -1.3. What is the difference between the Expenditure(as % of GDP) in Pacific island small states in 2006 and the Expenditure(as % of GDP) in Japan in 2008?
Keep it short and to the point. -3.24. What is the difference between the Expenditure(as % of GDP) in Pacific island small states in 2006 and the Expenditure(as % of GDP) in Uzbekistan in 2008?
Ensure brevity in your answer.  -0.56. What is the difference between the Expenditure(as % of GDP) in Japan in 2006 and the Expenditure(as % of GDP) in Uzbekistan in 2008?
Make the answer very short. 2.28. What is the difference between the Expenditure(as % of GDP) of Middle East & North Africa (developing only) in 2006 and the Expenditure(as % of GDP) of Pacific island small states in 2009?
Keep it short and to the point. -1.21. What is the difference between the Expenditure(as % of GDP) in Middle East & North Africa (developing only) in 2006 and the Expenditure(as % of GDP) in Japan in 2009?
Provide a short and direct response. -4.91. What is the difference between the Expenditure(as % of GDP) of Middle East & North Africa (developing only) in 2006 and the Expenditure(as % of GDP) of Uzbekistan in 2009?
Provide a succinct answer. -1.7. What is the difference between the Expenditure(as % of GDP) in Pacific island small states in 2006 and the Expenditure(as % of GDP) in Japan in 2009?
Provide a short and direct response. -4.16. What is the difference between the Expenditure(as % of GDP) of Pacific island small states in 2006 and the Expenditure(as % of GDP) of Uzbekistan in 2009?
Ensure brevity in your answer.  -0.95. What is the difference between the Expenditure(as % of GDP) in Japan in 2006 and the Expenditure(as % of GDP) in Uzbekistan in 2009?
Make the answer very short. 1.88. What is the difference between the Expenditure(as % of GDP) of Middle East & North Africa (developing only) in 2007 and the Expenditure(as % of GDP) of Pacific island small states in 2008?
Give a very brief answer. -0.4. What is the difference between the Expenditure(as % of GDP) in Middle East & North Africa (developing only) in 2007 and the Expenditure(as % of GDP) in Japan in 2008?
Provide a succinct answer. -3.87. What is the difference between the Expenditure(as % of GDP) of Middle East & North Africa (developing only) in 2007 and the Expenditure(as % of GDP) of Uzbekistan in 2008?
Your response must be concise. -1.18. What is the difference between the Expenditure(as % of GDP) in Pacific island small states in 2007 and the Expenditure(as % of GDP) in Japan in 2008?
Your response must be concise. -3.23. What is the difference between the Expenditure(as % of GDP) of Pacific island small states in 2007 and the Expenditure(as % of GDP) of Uzbekistan in 2008?
Your response must be concise. -0.54. What is the difference between the Expenditure(as % of GDP) in Japan in 2007 and the Expenditure(as % of GDP) in Uzbekistan in 2008?
Ensure brevity in your answer.  2.31. What is the difference between the Expenditure(as % of GDP) of Middle East & North Africa (developing only) in 2007 and the Expenditure(as % of GDP) of Pacific island small states in 2009?
Provide a succinct answer. -1.09. What is the difference between the Expenditure(as % of GDP) in Middle East & North Africa (developing only) in 2007 and the Expenditure(as % of GDP) in Japan in 2009?
Offer a terse response. -4.79. What is the difference between the Expenditure(as % of GDP) in Middle East & North Africa (developing only) in 2007 and the Expenditure(as % of GDP) in Uzbekistan in 2009?
Make the answer very short. -1.58. What is the difference between the Expenditure(as % of GDP) of Pacific island small states in 2007 and the Expenditure(as % of GDP) of Japan in 2009?
Provide a short and direct response. -4.15. What is the difference between the Expenditure(as % of GDP) of Pacific island small states in 2007 and the Expenditure(as % of GDP) of Uzbekistan in 2009?
Offer a very short reply. -0.94. What is the difference between the Expenditure(as % of GDP) of Japan in 2007 and the Expenditure(as % of GDP) of Uzbekistan in 2009?
Provide a succinct answer. 1.91. What is the difference between the Expenditure(as % of GDP) in Middle East & North Africa (developing only) in 2008 and the Expenditure(as % of GDP) in Pacific island small states in 2009?
Make the answer very short. -0.66. What is the difference between the Expenditure(as % of GDP) in Middle East & North Africa (developing only) in 2008 and the Expenditure(as % of GDP) in Japan in 2009?
Provide a succinct answer. -4.35. What is the difference between the Expenditure(as % of GDP) of Middle East & North Africa (developing only) in 2008 and the Expenditure(as % of GDP) of Uzbekistan in 2009?
Make the answer very short. -1.14. What is the difference between the Expenditure(as % of GDP) of Pacific island small states in 2008 and the Expenditure(as % of GDP) of Japan in 2009?
Provide a succinct answer. -4.38. What is the difference between the Expenditure(as % of GDP) of Pacific island small states in 2008 and the Expenditure(as % of GDP) of Uzbekistan in 2009?
Provide a succinct answer. -1.17. What is the difference between the Expenditure(as % of GDP) in Japan in 2008 and the Expenditure(as % of GDP) in Uzbekistan in 2009?
Keep it short and to the point. 2.29. What is the average Expenditure(as % of GDP) in Middle East & North Africa (developing only) per year?
Ensure brevity in your answer.  5.09. What is the average Expenditure(as % of GDP) in Pacific island small states per year?
Your response must be concise. 5.28. What is the average Expenditure(as % of GDP) of Japan per year?
Provide a short and direct response. 8.32. What is the average Expenditure(as % of GDP) in Uzbekistan per year?
Your answer should be compact. 5.55. In the year 2002, what is the difference between the Expenditure(as % of GDP) of Middle East & North Africa (developing only) and Expenditure(as % of GDP) of Pacific island small states?
Give a very brief answer. 0.26. In the year 2002, what is the difference between the Expenditure(as % of GDP) of Middle East & North Africa (developing only) and Expenditure(as % of GDP) of Japan?
Give a very brief answer. -2.41. In the year 2002, what is the difference between the Expenditure(as % of GDP) in Middle East & North Africa (developing only) and Expenditure(as % of GDP) in Uzbekistan?
Offer a terse response. 0.01. In the year 2002, what is the difference between the Expenditure(as % of GDP) of Pacific island small states and Expenditure(as % of GDP) of Japan?
Keep it short and to the point. -2.68. In the year 2002, what is the difference between the Expenditure(as % of GDP) in Pacific island small states and Expenditure(as % of GDP) in Uzbekistan?
Make the answer very short. -0.26. In the year 2002, what is the difference between the Expenditure(as % of GDP) in Japan and Expenditure(as % of GDP) in Uzbekistan?
Your response must be concise. 2.42. In the year 2003, what is the difference between the Expenditure(as % of GDP) in Middle East & North Africa (developing only) and Expenditure(as % of GDP) in Pacific island small states?
Offer a very short reply. 0.06. In the year 2003, what is the difference between the Expenditure(as % of GDP) in Middle East & North Africa (developing only) and Expenditure(as % of GDP) in Japan?
Offer a very short reply. -2.9. In the year 2003, what is the difference between the Expenditure(as % of GDP) of Middle East & North Africa (developing only) and Expenditure(as % of GDP) of Uzbekistan?
Your response must be concise. -0.08. In the year 2003, what is the difference between the Expenditure(as % of GDP) in Pacific island small states and Expenditure(as % of GDP) in Japan?
Your answer should be very brief. -2.96. In the year 2003, what is the difference between the Expenditure(as % of GDP) of Pacific island small states and Expenditure(as % of GDP) of Uzbekistan?
Make the answer very short. -0.14. In the year 2003, what is the difference between the Expenditure(as % of GDP) in Japan and Expenditure(as % of GDP) in Uzbekistan?
Keep it short and to the point. 2.82. In the year 2004, what is the difference between the Expenditure(as % of GDP) of Middle East & North Africa (developing only) and Expenditure(as % of GDP) of Pacific island small states?
Ensure brevity in your answer.  -0.15. In the year 2004, what is the difference between the Expenditure(as % of GDP) of Middle East & North Africa (developing only) and Expenditure(as % of GDP) of Japan?
Offer a terse response. -3.08. In the year 2004, what is the difference between the Expenditure(as % of GDP) in Middle East & North Africa (developing only) and Expenditure(as % of GDP) in Uzbekistan?
Your answer should be compact. -0.2. In the year 2004, what is the difference between the Expenditure(as % of GDP) in Pacific island small states and Expenditure(as % of GDP) in Japan?
Make the answer very short. -2.93. In the year 2004, what is the difference between the Expenditure(as % of GDP) in Pacific island small states and Expenditure(as % of GDP) in Uzbekistan?
Make the answer very short. -0.05. In the year 2004, what is the difference between the Expenditure(as % of GDP) of Japan and Expenditure(as % of GDP) of Uzbekistan?
Give a very brief answer. 2.88. In the year 2005, what is the difference between the Expenditure(as % of GDP) of Middle East & North Africa (developing only) and Expenditure(as % of GDP) of Pacific island small states?
Offer a very short reply. -0.52. In the year 2005, what is the difference between the Expenditure(as % of GDP) in Middle East & North Africa (developing only) and Expenditure(as % of GDP) in Japan?
Make the answer very short. -3.4. In the year 2005, what is the difference between the Expenditure(as % of GDP) of Pacific island small states and Expenditure(as % of GDP) of Japan?
Provide a succinct answer. -2.89. In the year 2005, what is the difference between the Expenditure(as % of GDP) in Pacific island small states and Expenditure(as % of GDP) in Uzbekistan?
Provide a short and direct response. 0.18. In the year 2005, what is the difference between the Expenditure(as % of GDP) of Japan and Expenditure(as % of GDP) of Uzbekistan?
Your answer should be compact. 3.07. In the year 2006, what is the difference between the Expenditure(as % of GDP) of Middle East & North Africa (developing only) and Expenditure(as % of GDP) of Pacific island small states?
Give a very brief answer. -0.75. In the year 2006, what is the difference between the Expenditure(as % of GDP) of Middle East & North Africa (developing only) and Expenditure(as % of GDP) of Japan?
Your answer should be very brief. -3.58. In the year 2006, what is the difference between the Expenditure(as % of GDP) of Middle East & North Africa (developing only) and Expenditure(as % of GDP) of Uzbekistan?
Ensure brevity in your answer.  -0.87. In the year 2006, what is the difference between the Expenditure(as % of GDP) in Pacific island small states and Expenditure(as % of GDP) in Japan?
Provide a short and direct response. -2.83. In the year 2006, what is the difference between the Expenditure(as % of GDP) of Pacific island small states and Expenditure(as % of GDP) of Uzbekistan?
Provide a succinct answer. -0.13. In the year 2006, what is the difference between the Expenditure(as % of GDP) in Japan and Expenditure(as % of GDP) in Uzbekistan?
Your response must be concise. 2.71. In the year 2007, what is the difference between the Expenditure(as % of GDP) in Middle East & North Africa (developing only) and Expenditure(as % of GDP) in Pacific island small states?
Provide a succinct answer. -0.64. In the year 2007, what is the difference between the Expenditure(as % of GDP) of Middle East & North Africa (developing only) and Expenditure(as % of GDP) of Japan?
Your response must be concise. -3.49. In the year 2007, what is the difference between the Expenditure(as % of GDP) of Middle East & North Africa (developing only) and Expenditure(as % of GDP) of Uzbekistan?
Offer a very short reply. -1.07. In the year 2007, what is the difference between the Expenditure(as % of GDP) of Pacific island small states and Expenditure(as % of GDP) of Japan?
Your response must be concise. -2.85. In the year 2007, what is the difference between the Expenditure(as % of GDP) of Pacific island small states and Expenditure(as % of GDP) of Uzbekistan?
Keep it short and to the point. -0.43. In the year 2007, what is the difference between the Expenditure(as % of GDP) in Japan and Expenditure(as % of GDP) in Uzbekistan?
Offer a terse response. 2.42. In the year 2008, what is the difference between the Expenditure(as % of GDP) in Middle East & North Africa (developing only) and Expenditure(as % of GDP) in Pacific island small states?
Make the answer very short. 0.03. In the year 2008, what is the difference between the Expenditure(as % of GDP) of Middle East & North Africa (developing only) and Expenditure(as % of GDP) of Japan?
Ensure brevity in your answer.  -3.43. In the year 2008, what is the difference between the Expenditure(as % of GDP) of Middle East & North Africa (developing only) and Expenditure(as % of GDP) of Uzbekistan?
Keep it short and to the point. -0.75. In the year 2008, what is the difference between the Expenditure(as % of GDP) in Pacific island small states and Expenditure(as % of GDP) in Japan?
Ensure brevity in your answer.  -3.46. In the year 2008, what is the difference between the Expenditure(as % of GDP) in Pacific island small states and Expenditure(as % of GDP) in Uzbekistan?
Your answer should be compact. -0.78. In the year 2008, what is the difference between the Expenditure(as % of GDP) in Japan and Expenditure(as % of GDP) in Uzbekistan?
Offer a very short reply. 2.68. In the year 2009, what is the difference between the Expenditure(as % of GDP) in Middle East & North Africa (developing only) and Expenditure(as % of GDP) in Pacific island small states?
Keep it short and to the point. 0.11. In the year 2009, what is the difference between the Expenditure(as % of GDP) in Middle East & North Africa (developing only) and Expenditure(as % of GDP) in Japan?
Keep it short and to the point. -3.58. In the year 2009, what is the difference between the Expenditure(as % of GDP) in Middle East & North Africa (developing only) and Expenditure(as % of GDP) in Uzbekistan?
Offer a very short reply. -0.37. In the year 2009, what is the difference between the Expenditure(as % of GDP) in Pacific island small states and Expenditure(as % of GDP) in Japan?
Provide a succinct answer. -3.69. In the year 2009, what is the difference between the Expenditure(as % of GDP) of Pacific island small states and Expenditure(as % of GDP) of Uzbekistan?
Your response must be concise. -0.48. In the year 2009, what is the difference between the Expenditure(as % of GDP) of Japan and Expenditure(as % of GDP) of Uzbekistan?
Your response must be concise. 3.21. What is the ratio of the Expenditure(as % of GDP) of Middle East & North Africa (developing only) in 2002 to that in 2003?
Your answer should be compact. 1.07. What is the ratio of the Expenditure(as % of GDP) in Pacific island small states in 2002 to that in 2003?
Provide a succinct answer. 1.03. What is the ratio of the Expenditure(as % of GDP) of Japan in 2002 to that in 2003?
Offer a terse response. 0.98. What is the ratio of the Expenditure(as % of GDP) in Uzbekistan in 2002 to that in 2003?
Your response must be concise. 1.05. What is the ratio of the Expenditure(as % of GDP) of Middle East & North Africa (developing only) in 2002 to that in 2004?
Your answer should be compact. 1.11. What is the ratio of the Expenditure(as % of GDP) in Pacific island small states in 2002 to that in 2004?
Offer a very short reply. 1.02. What is the ratio of the Expenditure(as % of GDP) of Japan in 2002 to that in 2004?
Give a very brief answer. 0.98. What is the ratio of the Expenditure(as % of GDP) in Uzbekistan in 2002 to that in 2004?
Your answer should be compact. 1.06. What is the ratio of the Expenditure(as % of GDP) in Middle East & North Africa (developing only) in 2002 to that in 2005?
Offer a very short reply. 1.14. What is the ratio of the Expenditure(as % of GDP) in Pacific island small states in 2002 to that in 2005?
Offer a very short reply. 0.98. What is the ratio of the Expenditure(as % of GDP) of Japan in 2002 to that in 2005?
Provide a short and direct response. 0.96. What is the ratio of the Expenditure(as % of GDP) of Uzbekistan in 2002 to that in 2005?
Keep it short and to the point. 1.06. What is the ratio of the Expenditure(as % of GDP) of Middle East & North Africa (developing only) in 2002 to that in 2006?
Keep it short and to the point. 1.18. What is the ratio of the Expenditure(as % of GDP) of Pacific island small states in 2002 to that in 2006?
Provide a succinct answer. 0.97. What is the ratio of the Expenditure(as % of GDP) of Japan in 2002 to that in 2006?
Provide a succinct answer. 0.96. What is the ratio of the Expenditure(as % of GDP) of Uzbekistan in 2002 to that in 2006?
Your response must be concise. 0.99. What is the ratio of the Expenditure(as % of GDP) in Middle East & North Africa (developing only) in 2002 to that in 2007?
Offer a very short reply. 1.15. What is the ratio of the Expenditure(as % of GDP) of Pacific island small states in 2002 to that in 2007?
Ensure brevity in your answer.  0.96. What is the ratio of the Expenditure(as % of GDP) in Japan in 2002 to that in 2007?
Offer a very short reply. 0.95. What is the ratio of the Expenditure(as % of GDP) in Uzbekistan in 2002 to that in 2007?
Give a very brief answer. 0.94. What is the ratio of the Expenditure(as % of GDP) in Middle East & North Africa (developing only) in 2002 to that in 2008?
Your answer should be compact. 1.05. What is the ratio of the Expenditure(as % of GDP) in Pacific island small states in 2002 to that in 2008?
Give a very brief answer. 1.01. What is the ratio of the Expenditure(as % of GDP) in Japan in 2002 to that in 2008?
Your answer should be compact. 0.91. What is the ratio of the Expenditure(as % of GDP) in Uzbekistan in 2002 to that in 2008?
Make the answer very short. 0.92. What is the ratio of the Expenditure(as % of GDP) of Middle East & North Africa (developing only) in 2002 to that in 2009?
Make the answer very short. 0.92. What is the ratio of the Expenditure(as % of GDP) in Pacific island small states in 2002 to that in 2009?
Your answer should be very brief. 0.89. What is the ratio of the Expenditure(as % of GDP) of Japan in 2002 to that in 2009?
Keep it short and to the point. 0.82. What is the ratio of the Expenditure(as % of GDP) in Uzbekistan in 2002 to that in 2009?
Provide a short and direct response. 0.86. What is the ratio of the Expenditure(as % of GDP) in Middle East & North Africa (developing only) in 2003 to that in 2004?
Provide a succinct answer. 1.03. What is the ratio of the Expenditure(as % of GDP) in Pacific island small states in 2003 to that in 2004?
Your answer should be compact. 0.99. What is the ratio of the Expenditure(as % of GDP) in Uzbekistan in 2003 to that in 2004?
Make the answer very short. 1.01. What is the ratio of the Expenditure(as % of GDP) in Middle East & North Africa (developing only) in 2003 to that in 2005?
Offer a very short reply. 1.06. What is the ratio of the Expenditure(as % of GDP) of Pacific island small states in 2003 to that in 2005?
Provide a succinct answer. 0.95. What is the ratio of the Expenditure(as % of GDP) of Japan in 2003 to that in 2005?
Keep it short and to the point. 0.98. What is the ratio of the Expenditure(as % of GDP) in Uzbekistan in 2003 to that in 2005?
Provide a short and direct response. 1.01. What is the ratio of the Expenditure(as % of GDP) in Middle East & North Africa (developing only) in 2003 to that in 2006?
Make the answer very short. 1.1. What is the ratio of the Expenditure(as % of GDP) in Pacific island small states in 2003 to that in 2006?
Make the answer very short. 0.94. What is the ratio of the Expenditure(as % of GDP) of Japan in 2003 to that in 2006?
Ensure brevity in your answer.  0.97. What is the ratio of the Expenditure(as % of GDP) in Uzbekistan in 2003 to that in 2006?
Make the answer very short. 0.94. What is the ratio of the Expenditure(as % of GDP) in Middle East & North Africa (developing only) in 2003 to that in 2007?
Give a very brief answer. 1.07. What is the ratio of the Expenditure(as % of GDP) of Pacific island small states in 2003 to that in 2007?
Ensure brevity in your answer.  0.93. What is the ratio of the Expenditure(as % of GDP) in Japan in 2003 to that in 2007?
Provide a succinct answer. 0.97. What is the ratio of the Expenditure(as % of GDP) of Uzbekistan in 2003 to that in 2007?
Make the answer very short. 0.89. What is the ratio of the Expenditure(as % of GDP) in Middle East & North Africa (developing only) in 2003 to that in 2008?
Offer a terse response. 0.98. What is the ratio of the Expenditure(as % of GDP) in Pacific island small states in 2003 to that in 2008?
Offer a very short reply. 0.98. What is the ratio of the Expenditure(as % of GDP) of Japan in 2003 to that in 2008?
Keep it short and to the point. 0.93. What is the ratio of the Expenditure(as % of GDP) of Uzbekistan in 2003 to that in 2008?
Provide a short and direct response. 0.87. What is the ratio of the Expenditure(as % of GDP) of Middle East & North Africa (developing only) in 2003 to that in 2009?
Offer a terse response. 0.86. What is the ratio of the Expenditure(as % of GDP) in Pacific island small states in 2003 to that in 2009?
Make the answer very short. 0.86. What is the ratio of the Expenditure(as % of GDP) of Japan in 2003 to that in 2009?
Offer a terse response. 0.84. What is the ratio of the Expenditure(as % of GDP) in Uzbekistan in 2003 to that in 2009?
Offer a very short reply. 0.82. What is the ratio of the Expenditure(as % of GDP) in Middle East & North Africa (developing only) in 2004 to that in 2005?
Offer a terse response. 1.03. What is the ratio of the Expenditure(as % of GDP) of Pacific island small states in 2004 to that in 2005?
Keep it short and to the point. 0.96. What is the ratio of the Expenditure(as % of GDP) in Japan in 2004 to that in 2005?
Make the answer very short. 0.98. What is the ratio of the Expenditure(as % of GDP) of Middle East & North Africa (developing only) in 2004 to that in 2006?
Offer a very short reply. 1.06. What is the ratio of the Expenditure(as % of GDP) in Pacific island small states in 2004 to that in 2006?
Offer a terse response. 0.94. What is the ratio of the Expenditure(as % of GDP) of Japan in 2004 to that in 2006?
Your answer should be compact. 0.98. What is the ratio of the Expenditure(as % of GDP) in Uzbekistan in 2004 to that in 2006?
Your response must be concise. 0.93. What is the ratio of the Expenditure(as % of GDP) in Middle East & North Africa (developing only) in 2004 to that in 2007?
Your response must be concise. 1.04. What is the ratio of the Expenditure(as % of GDP) in Pacific island small states in 2004 to that in 2007?
Your response must be concise. 0.94. What is the ratio of the Expenditure(as % of GDP) of Japan in 2004 to that in 2007?
Make the answer very short. 0.97. What is the ratio of the Expenditure(as % of GDP) of Uzbekistan in 2004 to that in 2007?
Provide a succinct answer. 0.88. What is the ratio of the Expenditure(as % of GDP) of Middle East & North Africa (developing only) in 2004 to that in 2008?
Make the answer very short. 0.95. What is the ratio of the Expenditure(as % of GDP) in Pacific island small states in 2004 to that in 2008?
Make the answer very short. 0.98. What is the ratio of the Expenditure(as % of GDP) in Japan in 2004 to that in 2008?
Offer a very short reply. 0.93. What is the ratio of the Expenditure(as % of GDP) in Uzbekistan in 2004 to that in 2008?
Your response must be concise. 0.86. What is the ratio of the Expenditure(as % of GDP) in Middle East & North Africa (developing only) in 2004 to that in 2009?
Your answer should be very brief. 0.83. What is the ratio of the Expenditure(as % of GDP) in Pacific island small states in 2004 to that in 2009?
Provide a succinct answer. 0.87. What is the ratio of the Expenditure(as % of GDP) of Japan in 2004 to that in 2009?
Ensure brevity in your answer.  0.84. What is the ratio of the Expenditure(as % of GDP) of Uzbekistan in 2004 to that in 2009?
Your answer should be compact. 0.81. What is the ratio of the Expenditure(as % of GDP) of Middle East & North Africa (developing only) in 2005 to that in 2006?
Provide a short and direct response. 1.03. What is the ratio of the Expenditure(as % of GDP) of Pacific island small states in 2005 to that in 2006?
Provide a short and direct response. 0.99. What is the ratio of the Expenditure(as % of GDP) of Japan in 2005 to that in 2006?
Your answer should be compact. 1. What is the ratio of the Expenditure(as % of GDP) of Uzbekistan in 2005 to that in 2006?
Your answer should be compact. 0.93. What is the ratio of the Expenditure(as % of GDP) of Middle East & North Africa (developing only) in 2005 to that in 2007?
Provide a short and direct response. 1.01. What is the ratio of the Expenditure(as % of GDP) in Uzbekistan in 2005 to that in 2007?
Your answer should be very brief. 0.88. What is the ratio of the Expenditure(as % of GDP) of Middle East & North Africa (developing only) in 2005 to that in 2008?
Give a very brief answer. 0.92. What is the ratio of the Expenditure(as % of GDP) in Pacific island small states in 2005 to that in 2008?
Ensure brevity in your answer.  1.03. What is the ratio of the Expenditure(as % of GDP) in Japan in 2005 to that in 2008?
Your answer should be compact. 0.95. What is the ratio of the Expenditure(as % of GDP) of Uzbekistan in 2005 to that in 2008?
Your response must be concise. 0.86. What is the ratio of the Expenditure(as % of GDP) in Middle East & North Africa (developing only) in 2005 to that in 2009?
Ensure brevity in your answer.  0.8. What is the ratio of the Expenditure(as % of GDP) of Pacific island small states in 2005 to that in 2009?
Your answer should be very brief. 0.91. What is the ratio of the Expenditure(as % of GDP) of Japan in 2005 to that in 2009?
Provide a short and direct response. 0.86. What is the ratio of the Expenditure(as % of GDP) in Uzbekistan in 2005 to that in 2009?
Provide a short and direct response. 0.81. What is the ratio of the Expenditure(as % of GDP) in Japan in 2006 to that in 2007?
Your answer should be compact. 1. What is the ratio of the Expenditure(as % of GDP) in Uzbekistan in 2006 to that in 2007?
Keep it short and to the point. 0.95. What is the ratio of the Expenditure(as % of GDP) of Middle East & North Africa (developing only) in 2006 to that in 2008?
Keep it short and to the point. 0.89. What is the ratio of the Expenditure(as % of GDP) of Pacific island small states in 2006 to that in 2008?
Give a very brief answer. 1.04. What is the ratio of the Expenditure(as % of GDP) of Japan in 2006 to that in 2008?
Your answer should be compact. 0.95. What is the ratio of the Expenditure(as % of GDP) in Uzbekistan in 2006 to that in 2008?
Provide a succinct answer. 0.93. What is the ratio of the Expenditure(as % of GDP) of Middle East & North Africa (developing only) in 2006 to that in 2009?
Your answer should be compact. 0.78. What is the ratio of the Expenditure(as % of GDP) in Pacific island small states in 2006 to that in 2009?
Your answer should be compact. 0.92. What is the ratio of the Expenditure(as % of GDP) in Japan in 2006 to that in 2009?
Offer a terse response. 0.86. What is the ratio of the Expenditure(as % of GDP) in Uzbekistan in 2006 to that in 2009?
Ensure brevity in your answer.  0.87. What is the ratio of the Expenditure(as % of GDP) in Middle East & North Africa (developing only) in 2007 to that in 2008?
Make the answer very short. 0.92. What is the ratio of the Expenditure(as % of GDP) in Pacific island small states in 2007 to that in 2008?
Offer a terse response. 1.05. What is the ratio of the Expenditure(as % of GDP) of Japan in 2007 to that in 2008?
Offer a terse response. 0.96. What is the ratio of the Expenditure(as % of GDP) of Uzbekistan in 2007 to that in 2008?
Offer a terse response. 0.98. What is the ratio of the Expenditure(as % of GDP) in Middle East & North Africa (developing only) in 2007 to that in 2009?
Offer a terse response. 0.8. What is the ratio of the Expenditure(as % of GDP) of Pacific island small states in 2007 to that in 2009?
Make the answer very short. 0.92. What is the ratio of the Expenditure(as % of GDP) in Japan in 2007 to that in 2009?
Your answer should be very brief. 0.86. What is the ratio of the Expenditure(as % of GDP) of Uzbekistan in 2007 to that in 2009?
Your response must be concise. 0.92. What is the ratio of the Expenditure(as % of GDP) in Middle East & North Africa (developing only) in 2008 to that in 2009?
Offer a very short reply. 0.87. What is the ratio of the Expenditure(as % of GDP) in Pacific island small states in 2008 to that in 2009?
Keep it short and to the point. 0.88. What is the ratio of the Expenditure(as % of GDP) in Japan in 2008 to that in 2009?
Give a very brief answer. 0.9. What is the ratio of the Expenditure(as % of GDP) of Uzbekistan in 2008 to that in 2009?
Offer a terse response. 0.94. What is the difference between the highest and the second highest Expenditure(as % of GDP) in Middle East & North Africa (developing only)?
Give a very brief answer. 0.5. What is the difference between the highest and the second highest Expenditure(as % of GDP) of Pacific island small states?
Provide a succinct answer. 0.45. What is the difference between the highest and the second highest Expenditure(as % of GDP) of Japan?
Provide a succinct answer. 0.92. What is the difference between the highest and the second highest Expenditure(as % of GDP) of Uzbekistan?
Offer a very short reply. 0.39. What is the difference between the highest and the lowest Expenditure(as % of GDP) in Middle East & North Africa (developing only)?
Provide a short and direct response. 1.32. What is the difference between the highest and the lowest Expenditure(as % of GDP) of Pacific island small states?
Offer a terse response. 0.81. What is the difference between the highest and the lowest Expenditure(as % of GDP) in Japan?
Keep it short and to the point. 1.67. What is the difference between the highest and the lowest Expenditure(as % of GDP) in Uzbekistan?
Offer a terse response. 1.2. 